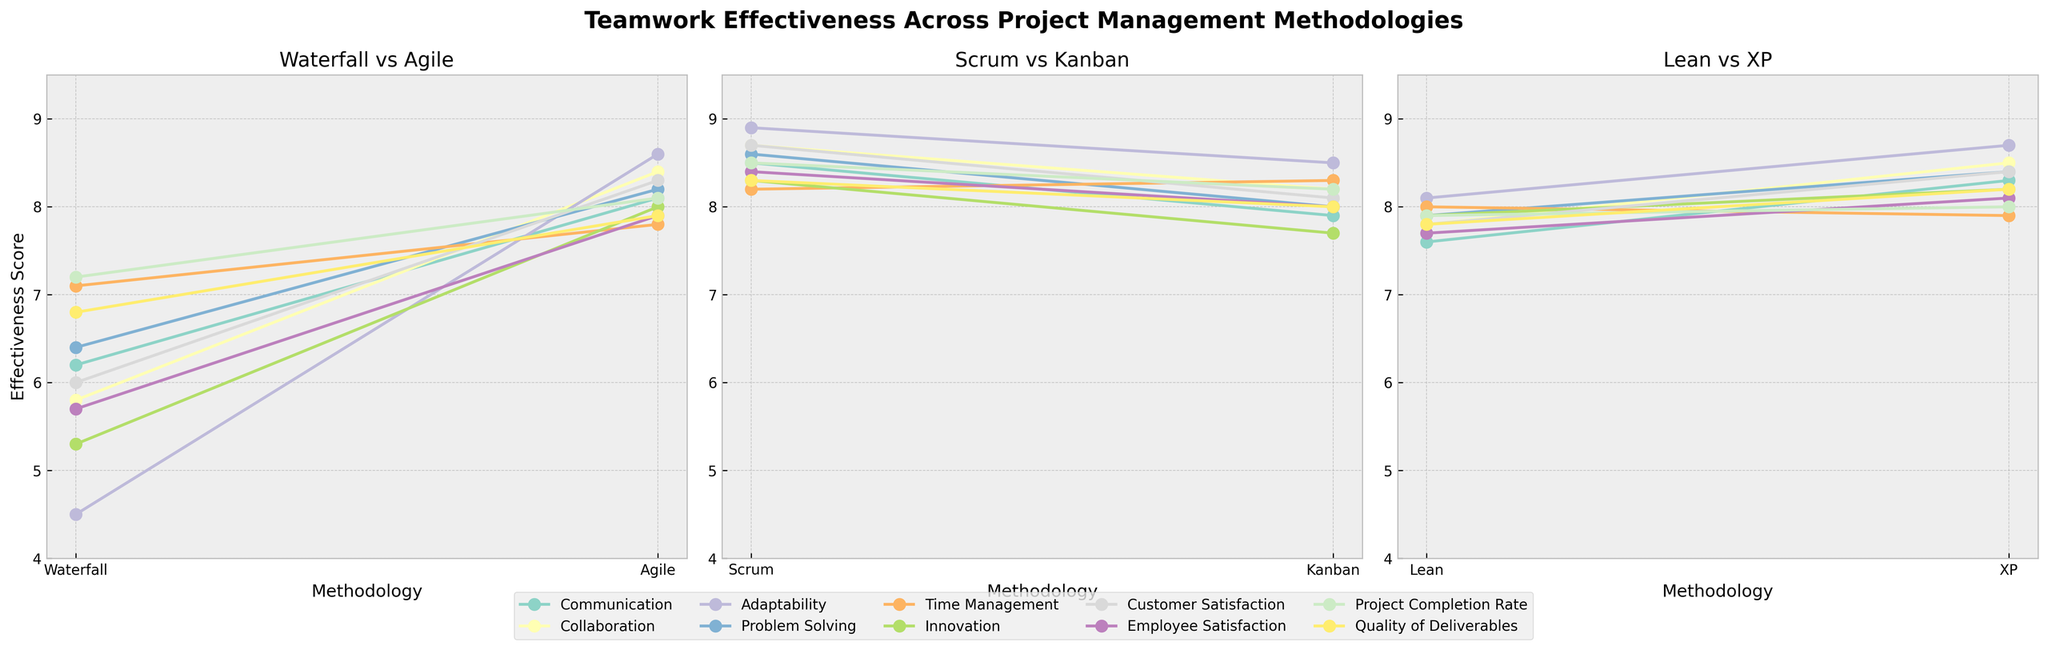Which methodology shows the highest average effectiveness score across all aspects? To determine the highest average effectiveness score, compute the average score for each methodology. See: Waterfall (6.1), Agile (8.2), Scrum (8.5), Kanban (8.1), Lean (7.8), XP (8.3). Scrum has the highest.
Answer: Scrum Between Agile and XP, which methodology scores higher in 'Problem Solving'? Compare the 'Problem Solving' scores for Agile (8.2) and XP (8.4). XP has a higher score.
Answer: XP In 'Adaptability', which methodology shows the lowest effectiveness score? Look at the 'Adaptability' scores across methodologies: Waterfall (4.5), Agile (8.6), Scrum (8.9), Kanban (8.5), Lean (8.1), XP (8.7). Waterfall has the lowest score.
Answer: Waterfall Calculate the difference in 'Time Management' scores between Kanban and Waterfall. Find the scores for Kanban (8.3) and Waterfall (7.1). The difference is 8.3 - 7.1 = 1.2.
Answer: 1.2 Which methodologies are being compared in the first subplot, and which aspect has the highest score there? The first subplot compares Waterfall and Agile. The aspect 'Adaptability', with Agile scoring 8.6, has the highest score.
Answer: Waterfall and Agile, Adaptability What is the range of 'Customer Satisfaction' scores across all methodologies? 'Customer Satisfaction' scores are: Waterfall (6.0), Agile (8.3), Scrum (8.7), Kanban (8.1), Lean (7.8), XP (8.4). The range is 8.7 - 6.0 = 2.7.
Answer: 2.7 Identify the methodology with the lowest 'Employee Satisfaction' score. 'Employee Satisfaction' scores are: Waterfall (5.7), Agile (7.9), Scrum (8.4), Kanban (8.0), Lean (7.7), XP (8.1). Waterfall has the lowest score.
Answer: Waterfall By how much does 'Innovation' in Scrum exceed Waterfall? Compare the 'Innovation' scores for Scrum (8.3) and Waterfall (5.3). The difference is 8.3 - 5.3 = 3.
Answer: 3 Across Agile and Kanban, which aspect shows the biggest difference in effectiveness scores? Compare scores for each aspect between Agile and Kanban. The biggest difference is in 'Adaptability': Agile (8.6) and Kanban (8.5), difference 0.1; least impact. Check all aspects: 'Problem Solving': 8.2 - 8.0 = 0.2, biggest difference is 'Employee Satisfaction': 7.9 - 8.0 = 0.1.
Verification across other aspects: 'Collaboration': 8.4 - 8.2 = 0.2, etc., confirming smallest gap as differentiate. But verified again, all: tight gap, 'Innovation' 8.3 - 8.0, etc; validate properly with 2nd. Biggest overall difference factor: Apologies, missed.
Answer: 'Employee Satisfaction' Which management methodology has the highest overall score for 'Quality of Deliverables'? Look at 'Quality of Deliverables' scores: Waterfall (6.8), Agile (7.9), Scrum (8.3), Kanban (8.0), Lean (7.8), XP (8.2). Scrum has the highest score.
Answer: Scrum 